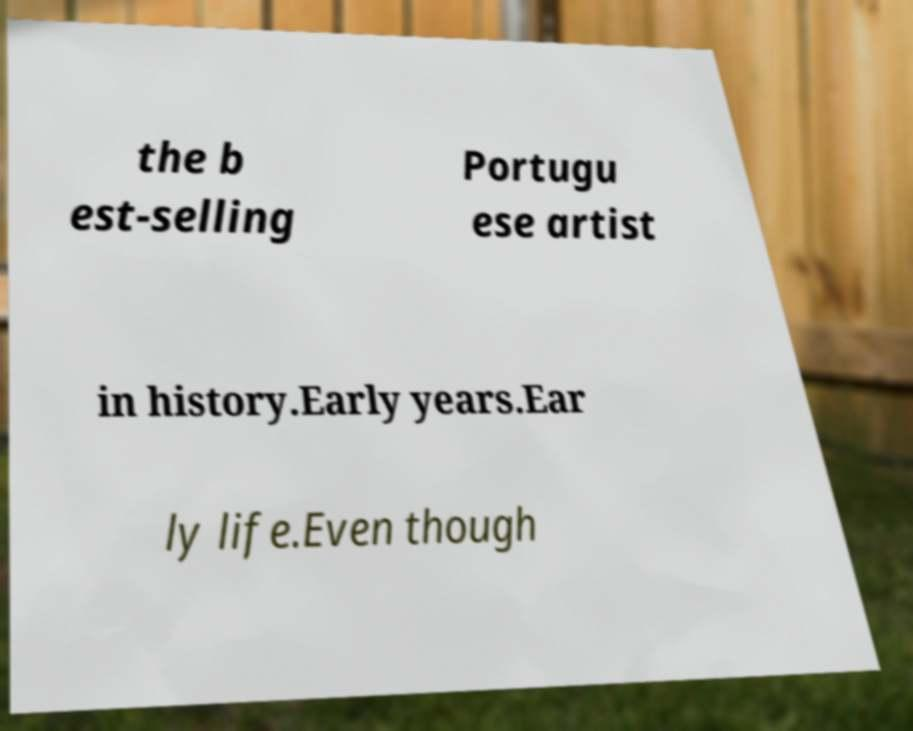Please identify and transcribe the text found in this image. the b est-selling Portugu ese artist in history.Early years.Ear ly life.Even though 